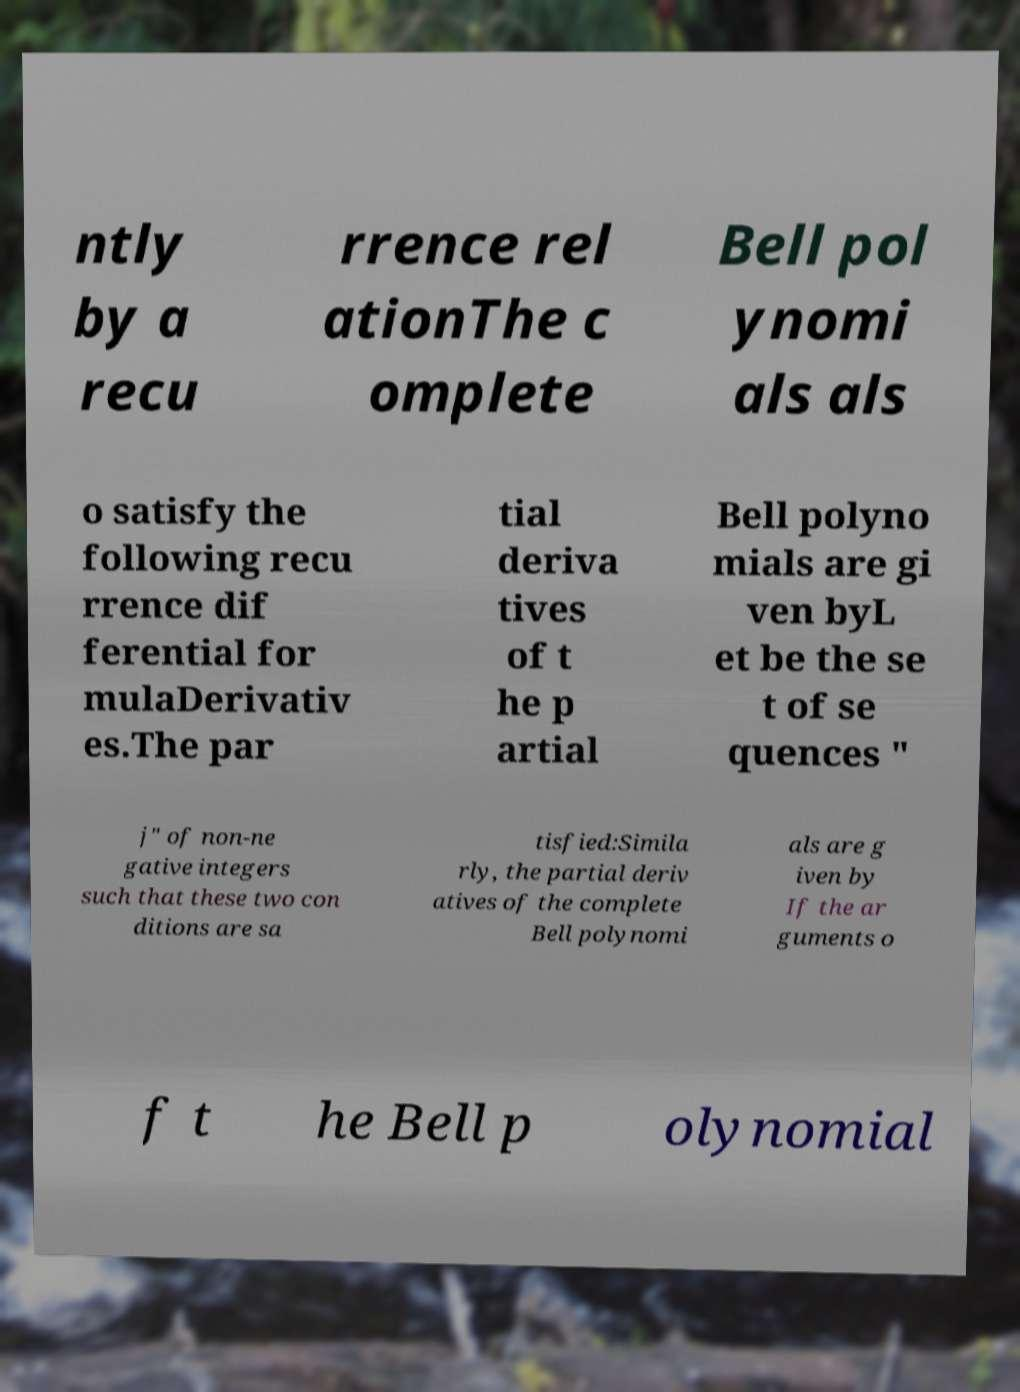For documentation purposes, I need the text within this image transcribed. Could you provide that? ntly by a recu rrence rel ationThe c omplete Bell pol ynomi als als o satisfy the following recu rrence dif ferential for mulaDerivativ es.The par tial deriva tives of t he p artial Bell polyno mials are gi ven byL et be the se t of se quences " j" of non-ne gative integers such that these two con ditions are sa tisfied:Simila rly, the partial deriv atives of the complete Bell polynomi als are g iven by If the ar guments o f t he Bell p olynomial 